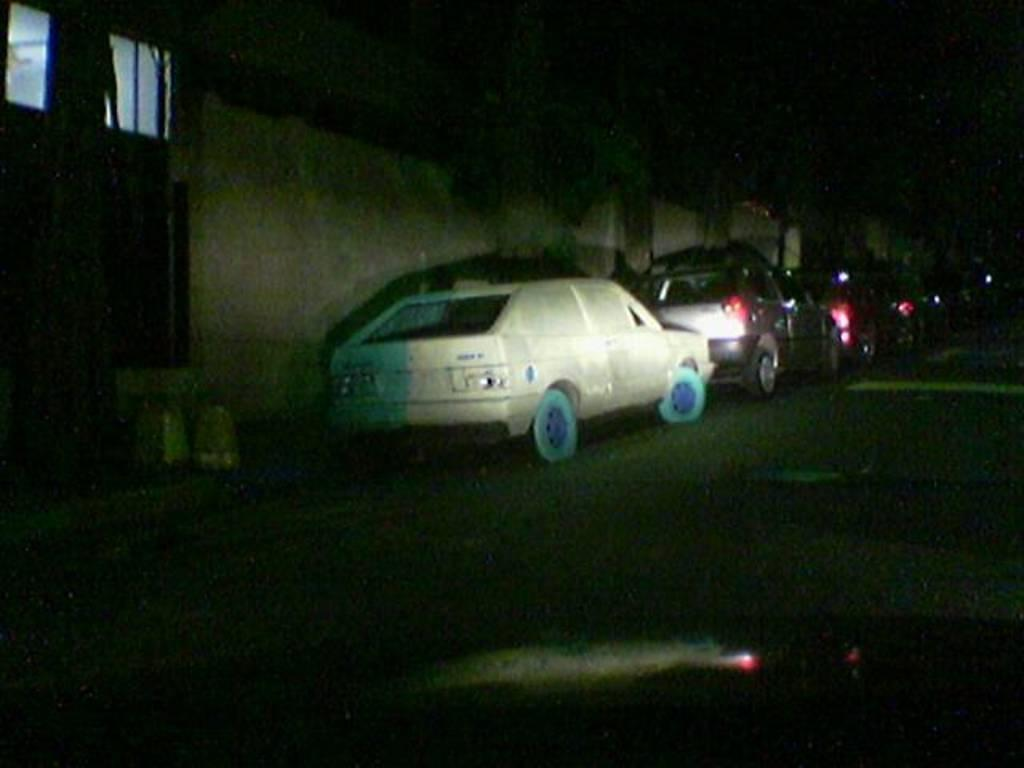What can be seen on the road in the image? There are cars on the road in the image. What is visible in the background of the image? There is a door, a window, and a wall in the background of the image. What type of furniture can be seen in the library in the image? There is no library or furniture present in the image. 